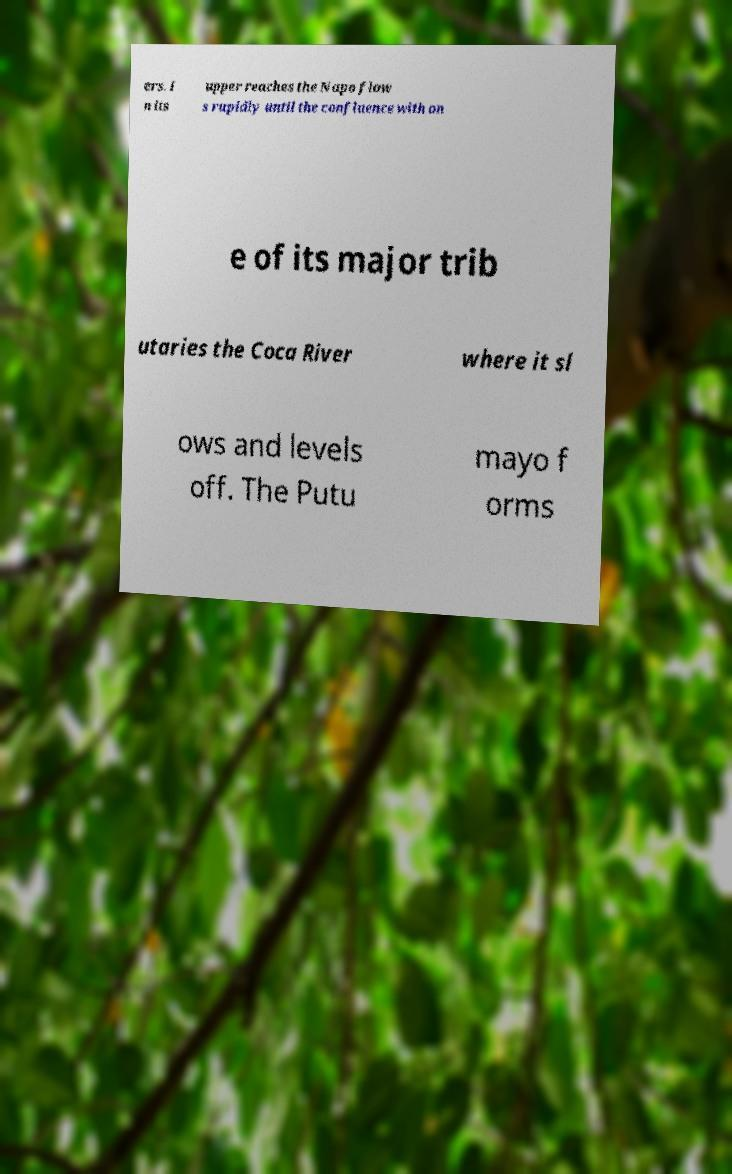Please read and relay the text visible in this image. What does it say? ers. I n its upper reaches the Napo flow s rapidly until the confluence with on e of its major trib utaries the Coca River where it sl ows and levels off. The Putu mayo f orms 